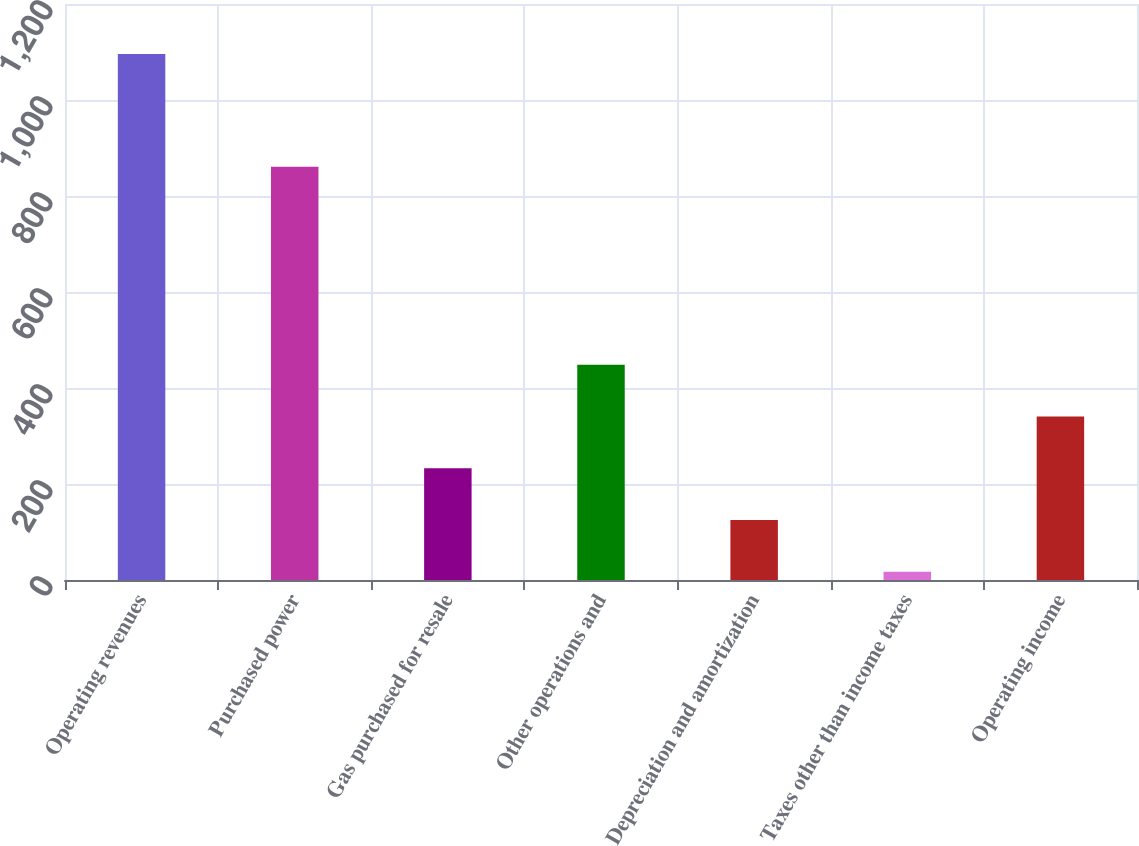Convert chart to OTSL. <chart><loc_0><loc_0><loc_500><loc_500><bar_chart><fcel>Operating revenues<fcel>Purchased power<fcel>Gas purchased for resale<fcel>Other operations and<fcel>Depreciation and amortization<fcel>Taxes other than income taxes<fcel>Operating income<nl><fcel>1096<fcel>861<fcel>232.8<fcel>448.6<fcel>124.9<fcel>17<fcel>340.7<nl></chart> 